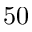Convert formula to latex. <formula><loc_0><loc_0><loc_500><loc_500>5 0</formula> 